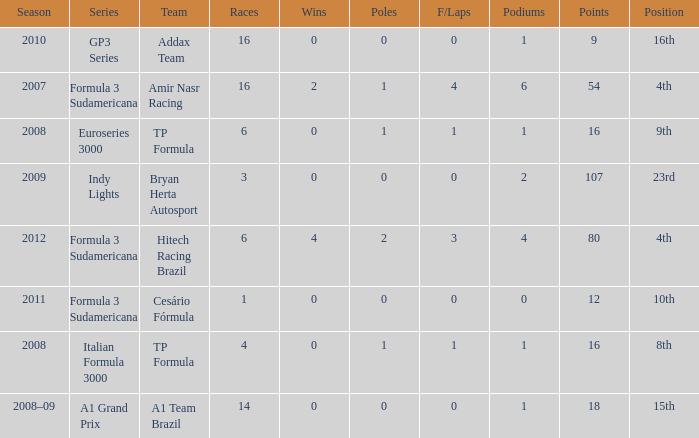How many points did he win in the race with more than 1.0 poles? 80.0. 